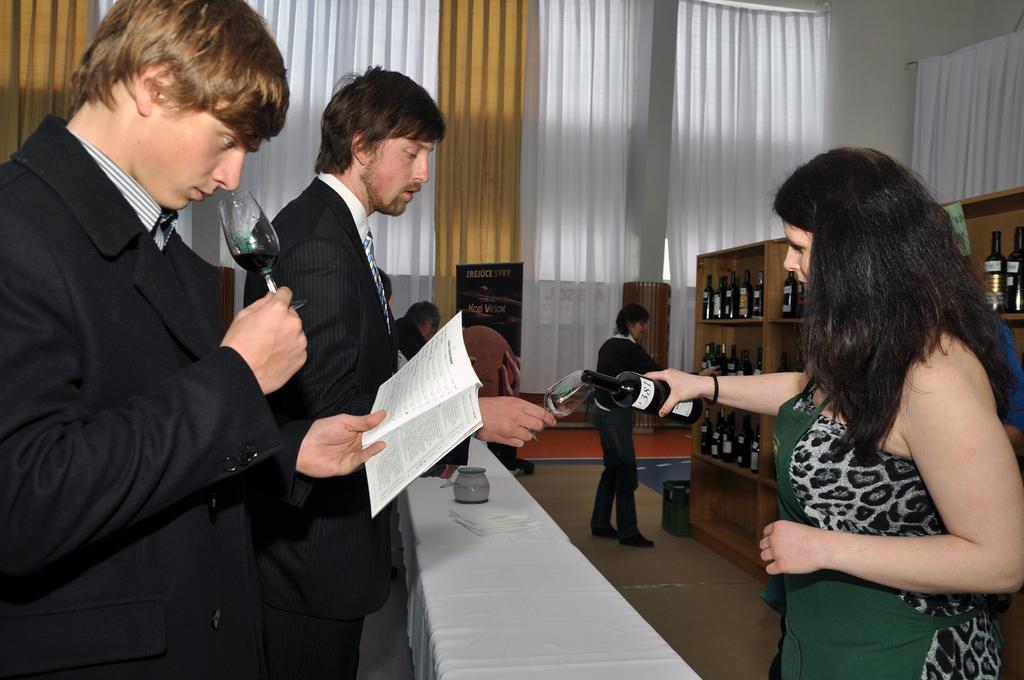Please provide a concise description of this image. In this picture I can observe some people standing on the floor. I can observe men and a woman. On the right side I can observe some bottles placed in the shelves. In the background I can observe white and brown color curtains. 